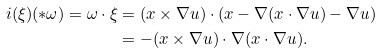<formula> <loc_0><loc_0><loc_500><loc_500>i ( \xi ) ( \ast \omega ) = \omega \cdot \xi & = ( x \times \nabla u ) \cdot ( x - \nabla ( x \cdot \nabla u ) - \nabla u ) \\ & = - ( x \times \nabla u ) \cdot \nabla ( x \cdot \nabla u ) .</formula> 